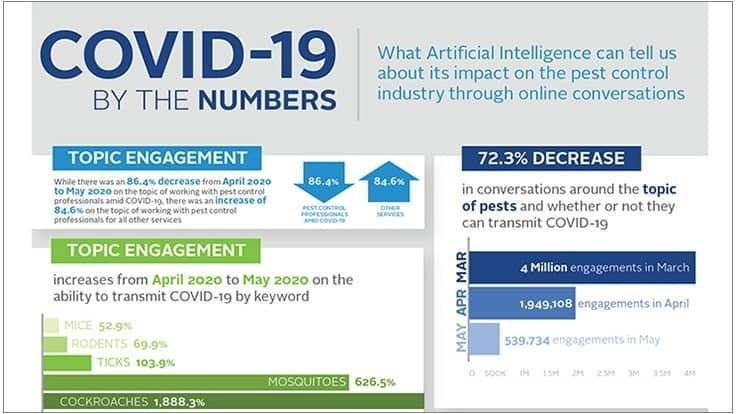In which month has the engagement been second least
Answer the question with a short phrase. April What is the difference in engagements in April and May 1409374 Which were the 2 pests on which the discussion was the highest in their ability to transmit COVID-19 Mosquitoes, Cockroaches 